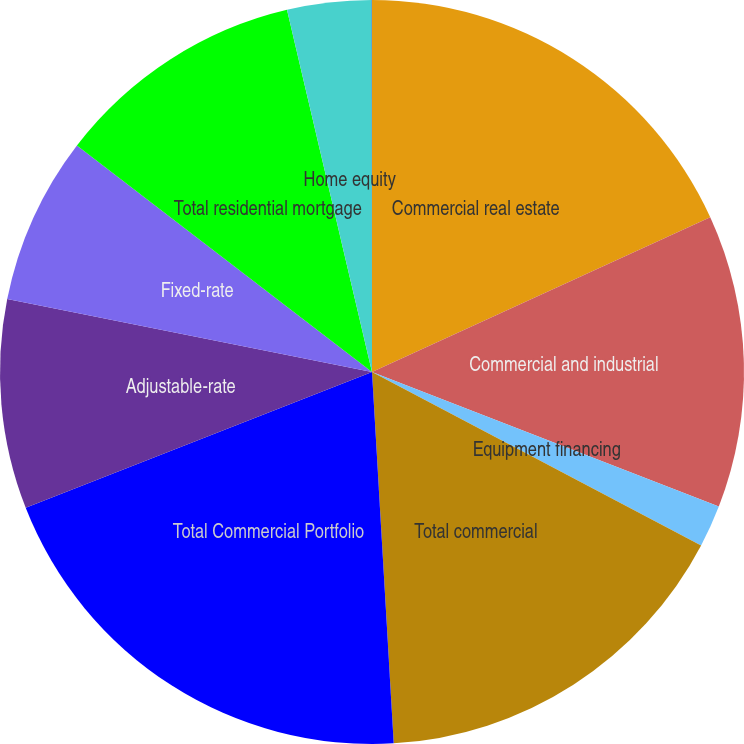<chart> <loc_0><loc_0><loc_500><loc_500><pie_chart><fcel>Commercial real estate<fcel>Commercial and industrial<fcel>Equipment financing<fcel>Total commercial<fcel>Total Commercial Portfolio<fcel>Adjustable-rate<fcel>Fixed-rate<fcel>Total residential mortgage<fcel>Home equity<fcel>Other consumer<nl><fcel>18.17%<fcel>12.72%<fcel>1.83%<fcel>16.35%<fcel>19.98%<fcel>9.09%<fcel>7.28%<fcel>10.91%<fcel>3.65%<fcel>0.02%<nl></chart> 